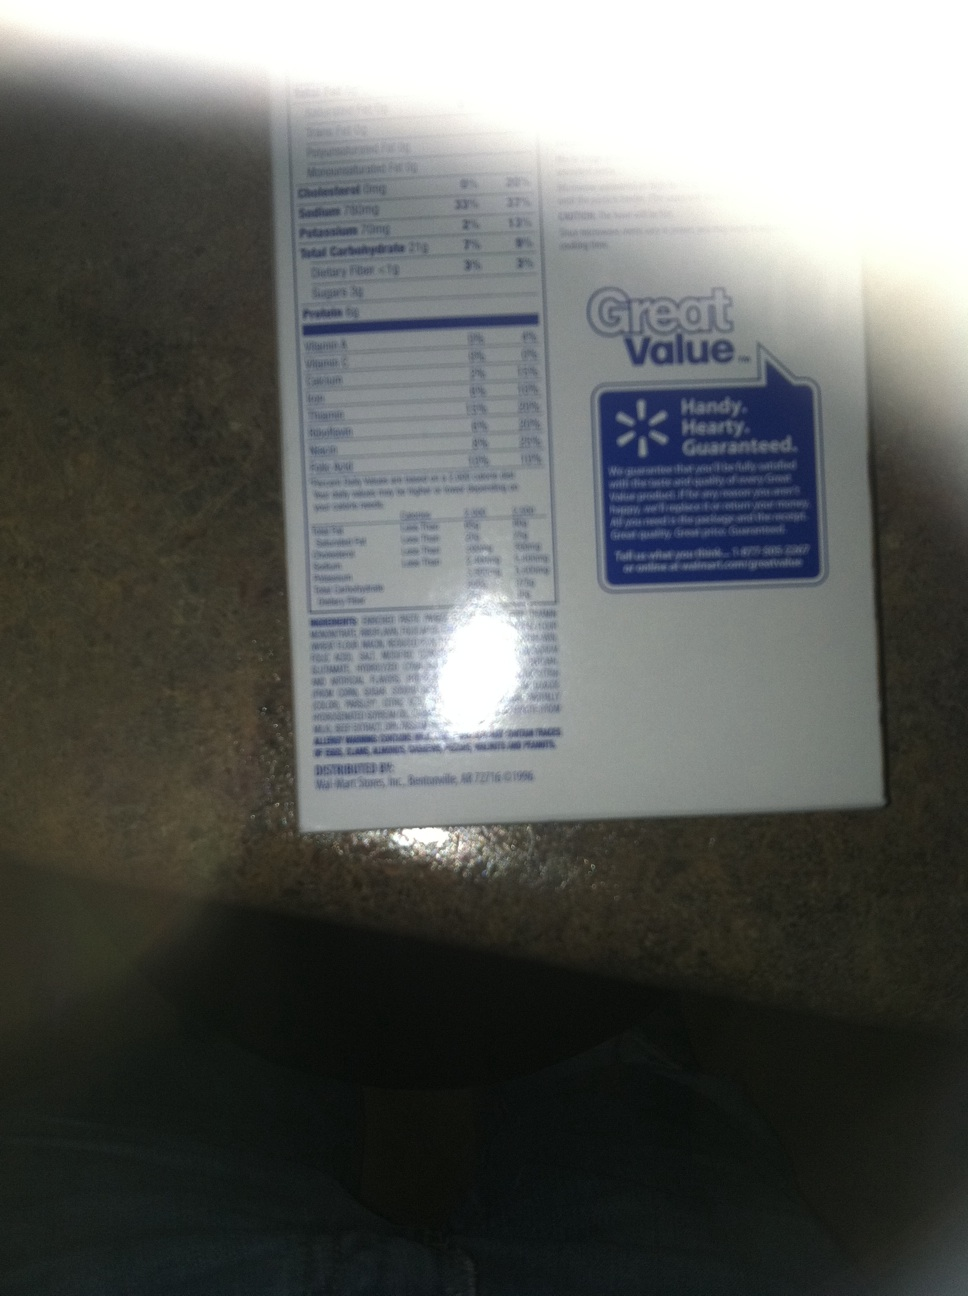what is this? from Vizwiz This image shows a food nutrition label from a 'Great Value' product. The label includes detailed nutritional information, such as serving size, calories, and the amount of various nutrients like cholesterol, sodium, and vitamins. 